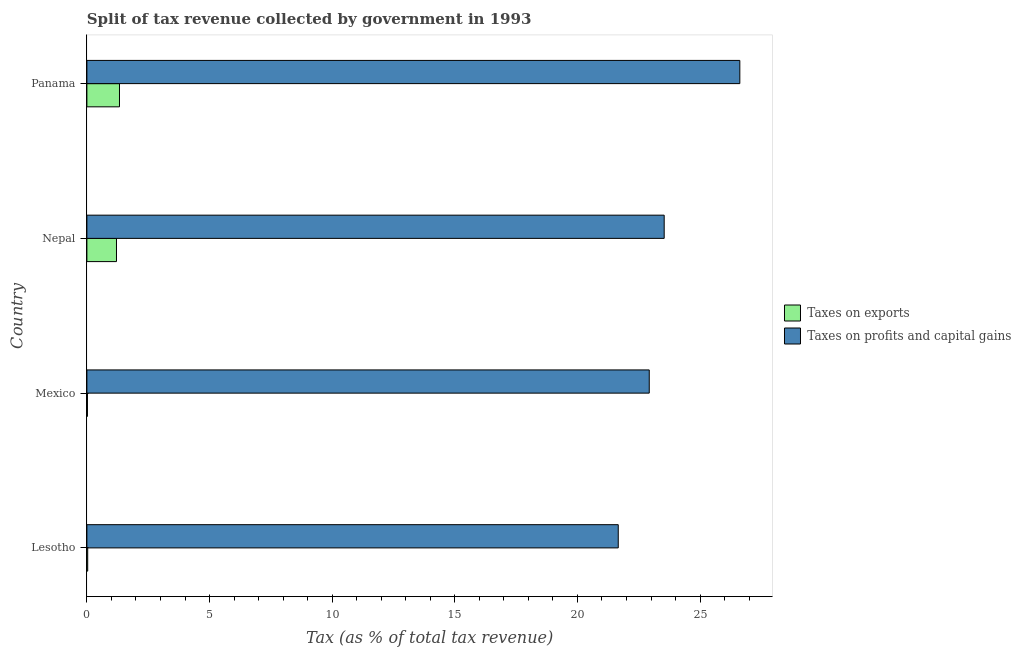How many different coloured bars are there?
Offer a very short reply. 2. Are the number of bars on each tick of the Y-axis equal?
Provide a succinct answer. Yes. How many bars are there on the 1st tick from the top?
Ensure brevity in your answer.  2. What is the label of the 2nd group of bars from the top?
Your answer should be compact. Nepal. In how many cases, is the number of bars for a given country not equal to the number of legend labels?
Your response must be concise. 0. What is the percentage of revenue obtained from taxes on exports in Panama?
Your answer should be very brief. 1.33. Across all countries, what is the maximum percentage of revenue obtained from taxes on profits and capital gains?
Ensure brevity in your answer.  26.62. Across all countries, what is the minimum percentage of revenue obtained from taxes on exports?
Give a very brief answer. 0.02. In which country was the percentage of revenue obtained from taxes on profits and capital gains maximum?
Make the answer very short. Panama. In which country was the percentage of revenue obtained from taxes on exports minimum?
Give a very brief answer. Mexico. What is the total percentage of revenue obtained from taxes on exports in the graph?
Provide a short and direct response. 2.59. What is the difference between the percentage of revenue obtained from taxes on exports in Lesotho and that in Nepal?
Give a very brief answer. -1.17. What is the difference between the percentage of revenue obtained from taxes on profits and capital gains in Panama and the percentage of revenue obtained from taxes on exports in Mexico?
Your answer should be compact. 26.6. What is the average percentage of revenue obtained from taxes on profits and capital gains per country?
Offer a very short reply. 23.69. What is the difference between the percentage of revenue obtained from taxes on exports and percentage of revenue obtained from taxes on profits and capital gains in Panama?
Offer a very short reply. -25.29. In how many countries, is the percentage of revenue obtained from taxes on profits and capital gains greater than 25 %?
Provide a short and direct response. 1. What is the ratio of the percentage of revenue obtained from taxes on exports in Lesotho to that in Mexico?
Provide a succinct answer. 1.52. What is the difference between the highest and the second highest percentage of revenue obtained from taxes on profits and capital gains?
Offer a very short reply. 3.08. What is the difference between the highest and the lowest percentage of revenue obtained from taxes on exports?
Your response must be concise. 1.31. Is the sum of the percentage of revenue obtained from taxes on profits and capital gains in Mexico and Panama greater than the maximum percentage of revenue obtained from taxes on exports across all countries?
Make the answer very short. Yes. What does the 1st bar from the top in Panama represents?
Keep it short and to the point. Taxes on profits and capital gains. What does the 1st bar from the bottom in Panama represents?
Your answer should be compact. Taxes on exports. How many bars are there?
Your answer should be very brief. 8. Are the values on the major ticks of X-axis written in scientific E-notation?
Your answer should be very brief. No. What is the title of the graph?
Your answer should be compact. Split of tax revenue collected by government in 1993. What is the label or title of the X-axis?
Offer a terse response. Tax (as % of total tax revenue). What is the Tax (as % of total tax revenue) of Taxes on exports in Lesotho?
Keep it short and to the point. 0.03. What is the Tax (as % of total tax revenue) in Taxes on profits and capital gains in Lesotho?
Your answer should be compact. 21.66. What is the Tax (as % of total tax revenue) in Taxes on exports in Mexico?
Keep it short and to the point. 0.02. What is the Tax (as % of total tax revenue) in Taxes on profits and capital gains in Mexico?
Give a very brief answer. 22.93. What is the Tax (as % of total tax revenue) in Taxes on exports in Nepal?
Make the answer very short. 1.21. What is the Tax (as % of total tax revenue) in Taxes on profits and capital gains in Nepal?
Make the answer very short. 23.54. What is the Tax (as % of total tax revenue) of Taxes on exports in Panama?
Provide a short and direct response. 1.33. What is the Tax (as % of total tax revenue) in Taxes on profits and capital gains in Panama?
Offer a terse response. 26.62. Across all countries, what is the maximum Tax (as % of total tax revenue) in Taxes on exports?
Your answer should be compact. 1.33. Across all countries, what is the maximum Tax (as % of total tax revenue) in Taxes on profits and capital gains?
Make the answer very short. 26.62. Across all countries, what is the minimum Tax (as % of total tax revenue) in Taxes on exports?
Your answer should be compact. 0.02. Across all countries, what is the minimum Tax (as % of total tax revenue) of Taxes on profits and capital gains?
Keep it short and to the point. 21.66. What is the total Tax (as % of total tax revenue) in Taxes on exports in the graph?
Make the answer very short. 2.59. What is the total Tax (as % of total tax revenue) of Taxes on profits and capital gains in the graph?
Offer a terse response. 94.75. What is the difference between the Tax (as % of total tax revenue) in Taxes on exports in Lesotho and that in Mexico?
Keep it short and to the point. 0.01. What is the difference between the Tax (as % of total tax revenue) in Taxes on profits and capital gains in Lesotho and that in Mexico?
Offer a terse response. -1.26. What is the difference between the Tax (as % of total tax revenue) in Taxes on exports in Lesotho and that in Nepal?
Keep it short and to the point. -1.17. What is the difference between the Tax (as % of total tax revenue) in Taxes on profits and capital gains in Lesotho and that in Nepal?
Give a very brief answer. -1.87. What is the difference between the Tax (as % of total tax revenue) of Taxes on exports in Lesotho and that in Panama?
Offer a terse response. -1.3. What is the difference between the Tax (as % of total tax revenue) of Taxes on profits and capital gains in Lesotho and that in Panama?
Make the answer very short. -4.96. What is the difference between the Tax (as % of total tax revenue) in Taxes on exports in Mexico and that in Nepal?
Your answer should be compact. -1.18. What is the difference between the Tax (as % of total tax revenue) of Taxes on profits and capital gains in Mexico and that in Nepal?
Your answer should be very brief. -0.61. What is the difference between the Tax (as % of total tax revenue) in Taxes on exports in Mexico and that in Panama?
Keep it short and to the point. -1.31. What is the difference between the Tax (as % of total tax revenue) of Taxes on profits and capital gains in Mexico and that in Panama?
Keep it short and to the point. -3.69. What is the difference between the Tax (as % of total tax revenue) in Taxes on exports in Nepal and that in Panama?
Your answer should be compact. -0.12. What is the difference between the Tax (as % of total tax revenue) of Taxes on profits and capital gains in Nepal and that in Panama?
Make the answer very short. -3.08. What is the difference between the Tax (as % of total tax revenue) in Taxes on exports in Lesotho and the Tax (as % of total tax revenue) in Taxes on profits and capital gains in Mexico?
Provide a short and direct response. -22.89. What is the difference between the Tax (as % of total tax revenue) in Taxes on exports in Lesotho and the Tax (as % of total tax revenue) in Taxes on profits and capital gains in Nepal?
Provide a short and direct response. -23.5. What is the difference between the Tax (as % of total tax revenue) in Taxes on exports in Lesotho and the Tax (as % of total tax revenue) in Taxes on profits and capital gains in Panama?
Provide a succinct answer. -26.59. What is the difference between the Tax (as % of total tax revenue) in Taxes on exports in Mexico and the Tax (as % of total tax revenue) in Taxes on profits and capital gains in Nepal?
Make the answer very short. -23.51. What is the difference between the Tax (as % of total tax revenue) of Taxes on exports in Mexico and the Tax (as % of total tax revenue) of Taxes on profits and capital gains in Panama?
Your response must be concise. -26.6. What is the difference between the Tax (as % of total tax revenue) in Taxes on exports in Nepal and the Tax (as % of total tax revenue) in Taxes on profits and capital gains in Panama?
Provide a short and direct response. -25.41. What is the average Tax (as % of total tax revenue) of Taxes on exports per country?
Keep it short and to the point. 0.65. What is the average Tax (as % of total tax revenue) of Taxes on profits and capital gains per country?
Provide a succinct answer. 23.69. What is the difference between the Tax (as % of total tax revenue) of Taxes on exports and Tax (as % of total tax revenue) of Taxes on profits and capital gains in Lesotho?
Provide a short and direct response. -21.63. What is the difference between the Tax (as % of total tax revenue) in Taxes on exports and Tax (as % of total tax revenue) in Taxes on profits and capital gains in Mexico?
Your answer should be compact. -22.91. What is the difference between the Tax (as % of total tax revenue) of Taxes on exports and Tax (as % of total tax revenue) of Taxes on profits and capital gains in Nepal?
Make the answer very short. -22.33. What is the difference between the Tax (as % of total tax revenue) of Taxes on exports and Tax (as % of total tax revenue) of Taxes on profits and capital gains in Panama?
Offer a very short reply. -25.29. What is the ratio of the Tax (as % of total tax revenue) of Taxes on exports in Lesotho to that in Mexico?
Make the answer very short. 1.52. What is the ratio of the Tax (as % of total tax revenue) of Taxes on profits and capital gains in Lesotho to that in Mexico?
Your response must be concise. 0.94. What is the ratio of the Tax (as % of total tax revenue) of Taxes on exports in Lesotho to that in Nepal?
Provide a short and direct response. 0.03. What is the ratio of the Tax (as % of total tax revenue) in Taxes on profits and capital gains in Lesotho to that in Nepal?
Make the answer very short. 0.92. What is the ratio of the Tax (as % of total tax revenue) of Taxes on exports in Lesotho to that in Panama?
Your answer should be compact. 0.03. What is the ratio of the Tax (as % of total tax revenue) in Taxes on profits and capital gains in Lesotho to that in Panama?
Keep it short and to the point. 0.81. What is the ratio of the Tax (as % of total tax revenue) in Taxes on exports in Mexico to that in Nepal?
Provide a short and direct response. 0.02. What is the ratio of the Tax (as % of total tax revenue) in Taxes on profits and capital gains in Mexico to that in Nepal?
Give a very brief answer. 0.97. What is the ratio of the Tax (as % of total tax revenue) of Taxes on exports in Mexico to that in Panama?
Provide a succinct answer. 0.02. What is the ratio of the Tax (as % of total tax revenue) of Taxes on profits and capital gains in Mexico to that in Panama?
Your answer should be very brief. 0.86. What is the ratio of the Tax (as % of total tax revenue) of Taxes on exports in Nepal to that in Panama?
Your response must be concise. 0.91. What is the ratio of the Tax (as % of total tax revenue) in Taxes on profits and capital gains in Nepal to that in Panama?
Provide a succinct answer. 0.88. What is the difference between the highest and the second highest Tax (as % of total tax revenue) in Taxes on exports?
Give a very brief answer. 0.12. What is the difference between the highest and the second highest Tax (as % of total tax revenue) in Taxes on profits and capital gains?
Ensure brevity in your answer.  3.08. What is the difference between the highest and the lowest Tax (as % of total tax revenue) in Taxes on exports?
Keep it short and to the point. 1.31. What is the difference between the highest and the lowest Tax (as % of total tax revenue) in Taxes on profits and capital gains?
Offer a terse response. 4.96. 